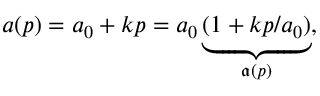Convert formula to latex. <formula><loc_0><loc_0><loc_500><loc_500>a ( p ) = a _ { 0 } + k p = a _ { 0 } \underbrace { ( 1 + k p / a _ { 0 } ) } _ { \mathfrak { a } ( p ) } ,</formula> 